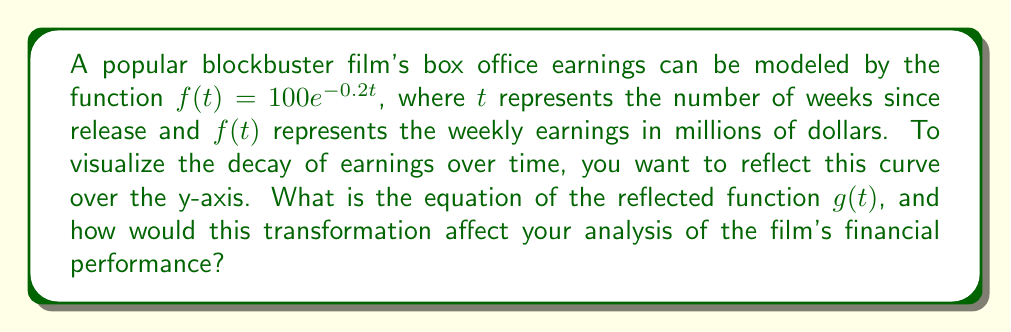Provide a solution to this math problem. To reflect the function $f(t) = 100e^{-0.2t}$ over the y-axis, we need to apply the following steps:

1. Identify the transformation: Reflection over the y-axis changes the sign of the input variable (t in this case).

2. Apply the transformation: Replace every t with -t in the original function.

   $f(t) = 100e^{-0.2t}$ becomes $g(t) = 100e^{-0.2(-t)}$

3. Simplify the exponent:
   $g(t) = 100e^{0.2t}$

The reflected function $g(t) = 100e^{0.2t}$ represents an exponential growth curve instead of decay.

Analyzing this transformation:

- The y-intercept (initial earnings) remains the same at $100 million.
- As t increases, $g(t)$ increases exponentially, contrary to the original decaying model.
- This reflection essentially "reverses time," showing what the earnings curve would look like if it grew at the same rate it originally decayed.

For a film blogger, this transformation could be used to:
- Visualize the stark contrast between actual earnings decay and a hypothetical growth scenario.
- Discuss how different the film's performance would be if it had sustained growth instead of decay.
- Analyze the steepness of the decay by comparing it to an equivalent growth curve.
Answer: The equation of the reflected function is $g(t) = 100e^{0.2t}$. This reflection over the y-axis transforms the original decay model into a growth model, inverting the trend of earnings over time while maintaining the same rate of change and initial value. 